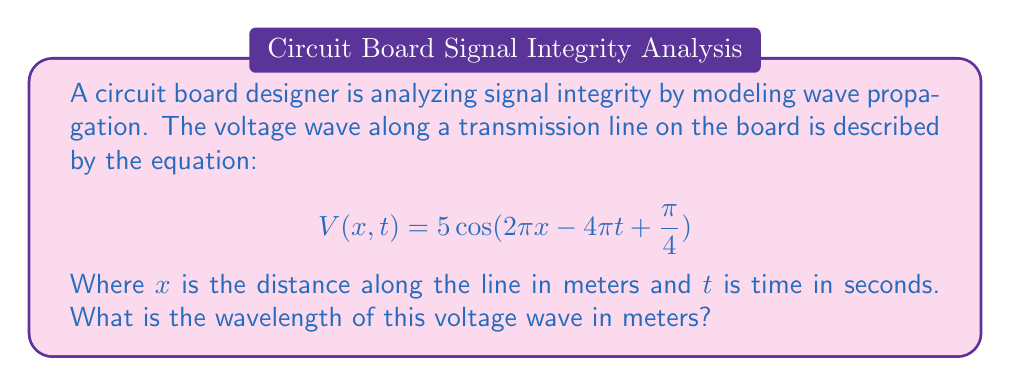What is the answer to this math problem? To find the wavelength, we need to analyze the spatial component of the wave equation:

1) The general form of a traveling wave is:
   $$A\cos(kx - \omega t + \phi)$$
   where $k$ is the wave number and $\omega$ is the angular frequency.

2) Comparing our equation to the general form:
   $$5\cos(2\pi x - 4\pi t + \frac{\pi}{4})$$
   We can identify that $k = 2\pi$

3) The wave number $k$ is related to the wavelength $\lambda$ by:
   $$k = \frac{2\pi}{\lambda}$$

4) Substituting our value of $k$:
   $$2\pi = \frac{2\pi}{\lambda}$$

5) Solving for $\lambda$:
   $$\lambda = \frac{2\pi}{2\pi} = 1$$

Therefore, the wavelength is 1 meter.
Answer: 1 meter 